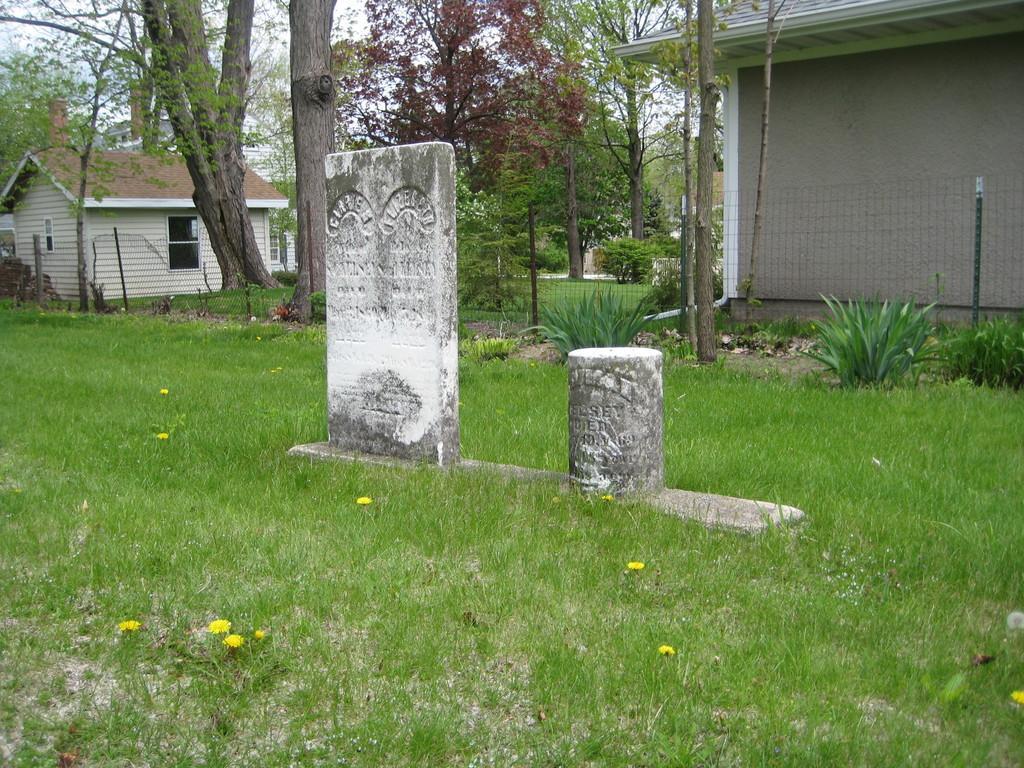Please provide a concise description of this image. In the image there are tombstone on the grassland, behind it there is a fence with fence and trees behind it and two buildings on either side. 